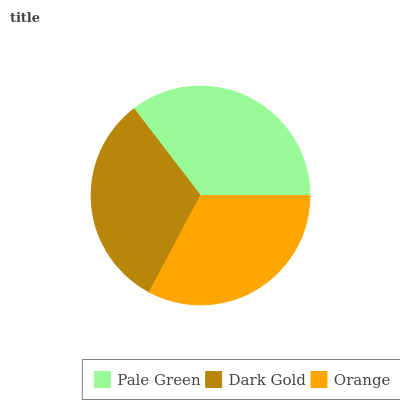Is Dark Gold the minimum?
Answer yes or no. Yes. Is Pale Green the maximum?
Answer yes or no. Yes. Is Orange the minimum?
Answer yes or no. No. Is Orange the maximum?
Answer yes or no. No. Is Orange greater than Dark Gold?
Answer yes or no. Yes. Is Dark Gold less than Orange?
Answer yes or no. Yes. Is Dark Gold greater than Orange?
Answer yes or no. No. Is Orange less than Dark Gold?
Answer yes or no. No. Is Orange the high median?
Answer yes or no. Yes. Is Orange the low median?
Answer yes or no. Yes. Is Pale Green the high median?
Answer yes or no. No. Is Pale Green the low median?
Answer yes or no. No. 